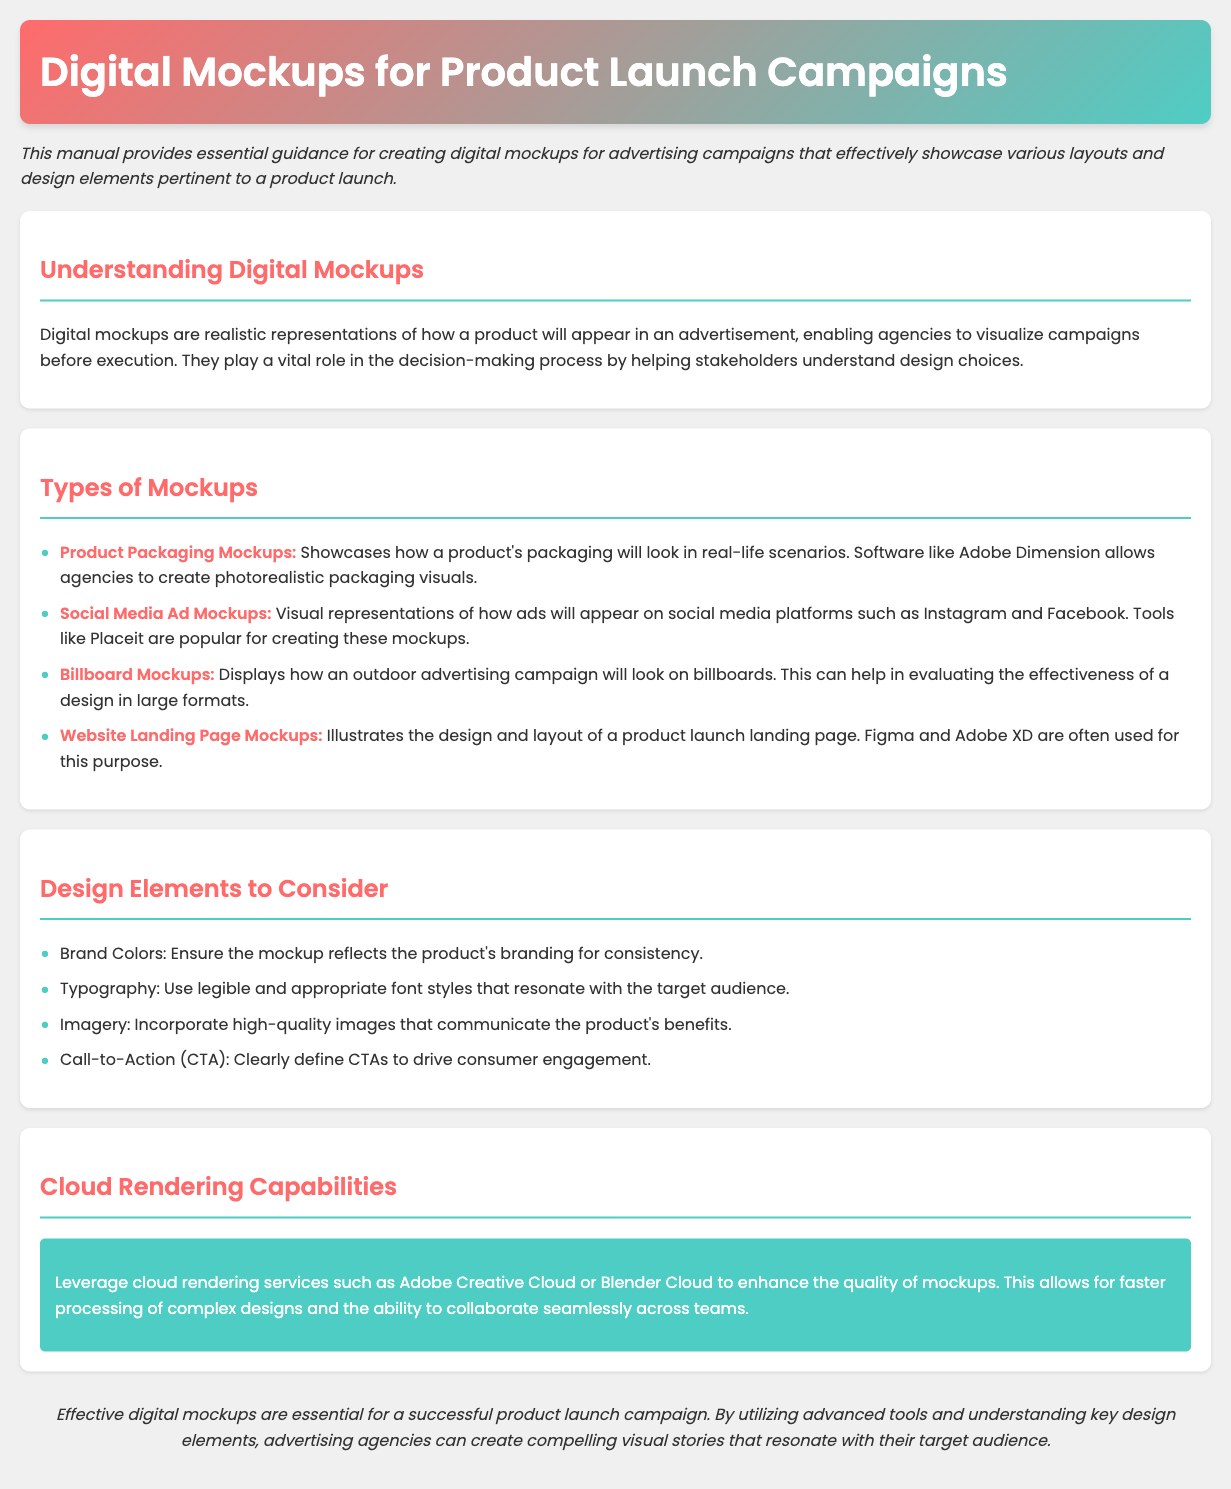what is the title of the document? The title of the document is mentioned in the header section.
Answer: Digital Mockups for Product Launch Campaigns what is the purpose of digital mockups? The purpose is explained in the introduction paragraph of the document.
Answer: To visualize campaigns before execution which software is mentioned for creating product packaging mockups? The software is listed in the types of mockups section.
Answer: Adobe Dimension name one tool for creating social media ad mockups. The tool is mentioned specifically in the types of mockups section.
Answer: Placeit what color is used for the mockup type headings? The color of the headings is stated in the styles applied to specific sections of the document.
Answer: #ff6b6b which design element ensures branding consistency? The design elements are listed in the respective section of the document.
Answer: Brand Colors how many types of mockups are listed in the document? The total number of types is calculated from the list provided in the document.
Answer: Four what cloud rendering service is mentioned in the document? The service is specified in the cloud rendering capabilities section.
Answer: Adobe Creative Cloud what is the concluding statement of the document? The conclusion summarizes the importance of digital mockups stated at the end of the document.
Answer: Effective digital mockups are essential for a successful product launch campaign 